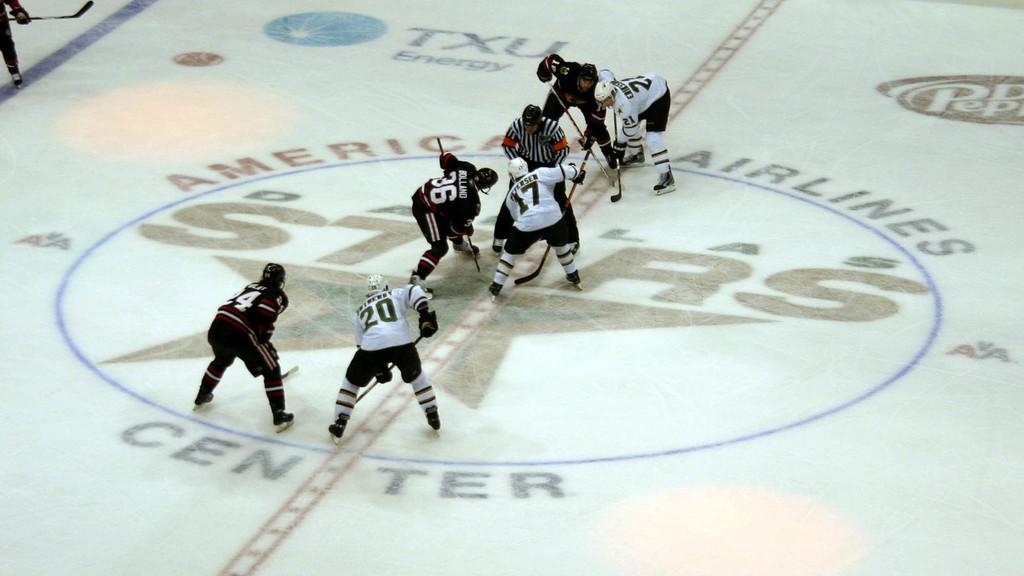How many people are in the image? There are multiple persons in the image. What activity are the persons engaged in? The persons are playing hockey. What is the surface on which the hockey game is taking place? There is a ground at the bottom of the image. What protective gear are the persons wearing? The persons are wearing helmets. What clothing items are the persons wearing that indicate their team affiliation? The persons are wearing jerseys. What equipment are the persons using to play hockey? The persons are holding hockey sticks. What type of faucet can be seen in the image? There is no faucet present in the image. 